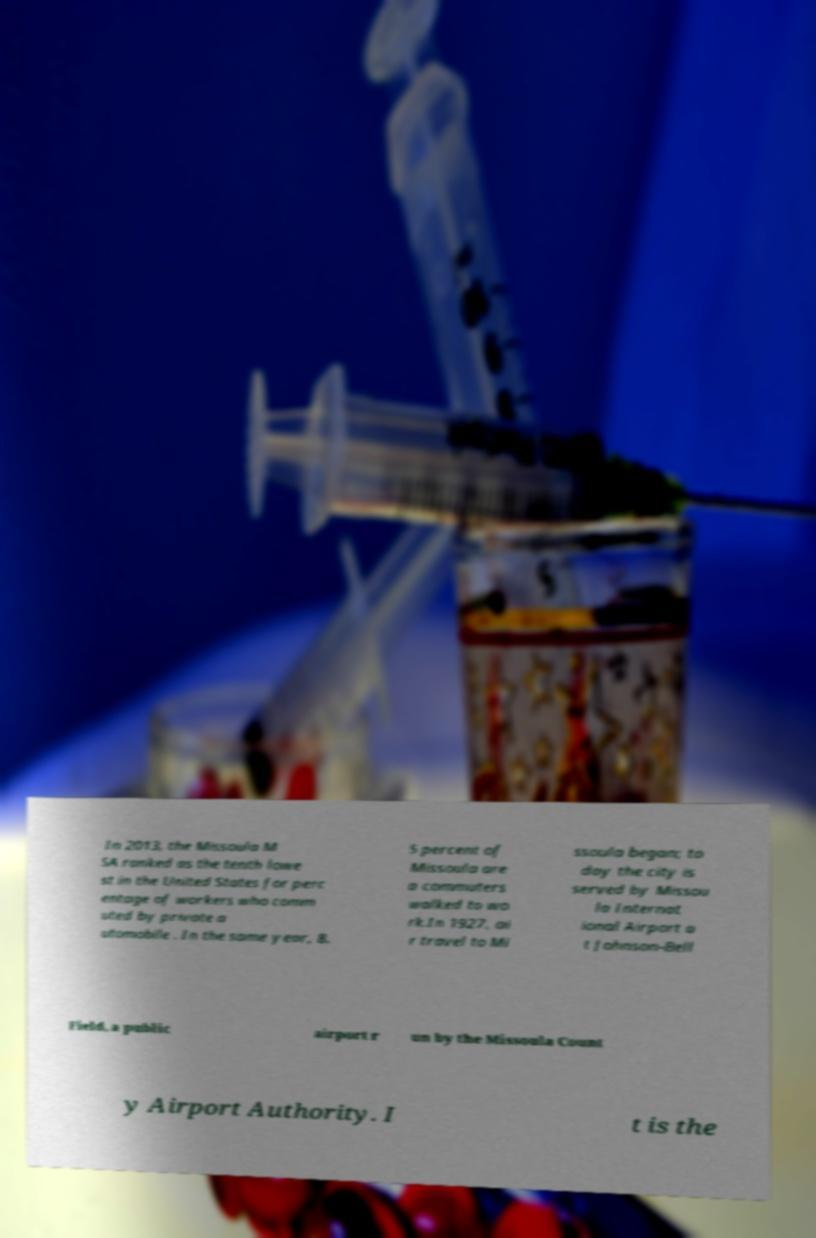Please read and relay the text visible in this image. What does it say? In 2013, the Missoula M SA ranked as the tenth lowe st in the United States for perc entage of workers who comm uted by private a utomobile . In the same year, 8. 5 percent of Missoula are a commuters walked to wo rk.In 1927, ai r travel to Mi ssoula began; to day the city is served by Missou la Internat ional Airport a t Johnson-Bell Field, a public airport r un by the Missoula Count y Airport Authority. I t is the 